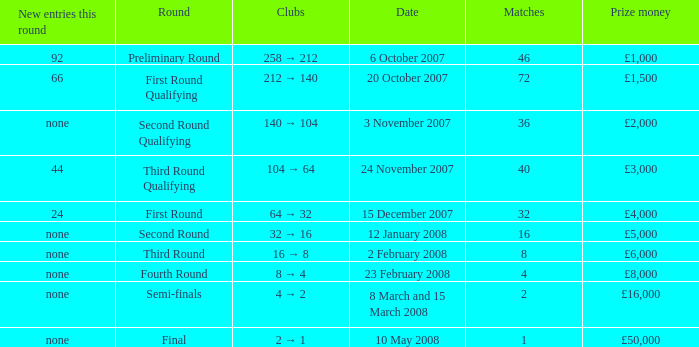What is the average for matches with a prize money amount of £3,000? 40.0. 